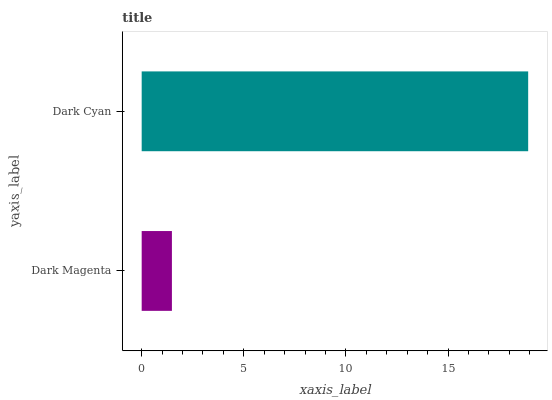Is Dark Magenta the minimum?
Answer yes or no. Yes. Is Dark Cyan the maximum?
Answer yes or no. Yes. Is Dark Cyan the minimum?
Answer yes or no. No. Is Dark Cyan greater than Dark Magenta?
Answer yes or no. Yes. Is Dark Magenta less than Dark Cyan?
Answer yes or no. Yes. Is Dark Magenta greater than Dark Cyan?
Answer yes or no. No. Is Dark Cyan less than Dark Magenta?
Answer yes or no. No. Is Dark Cyan the high median?
Answer yes or no. Yes. Is Dark Magenta the low median?
Answer yes or no. Yes. Is Dark Magenta the high median?
Answer yes or no. No. Is Dark Cyan the low median?
Answer yes or no. No. 